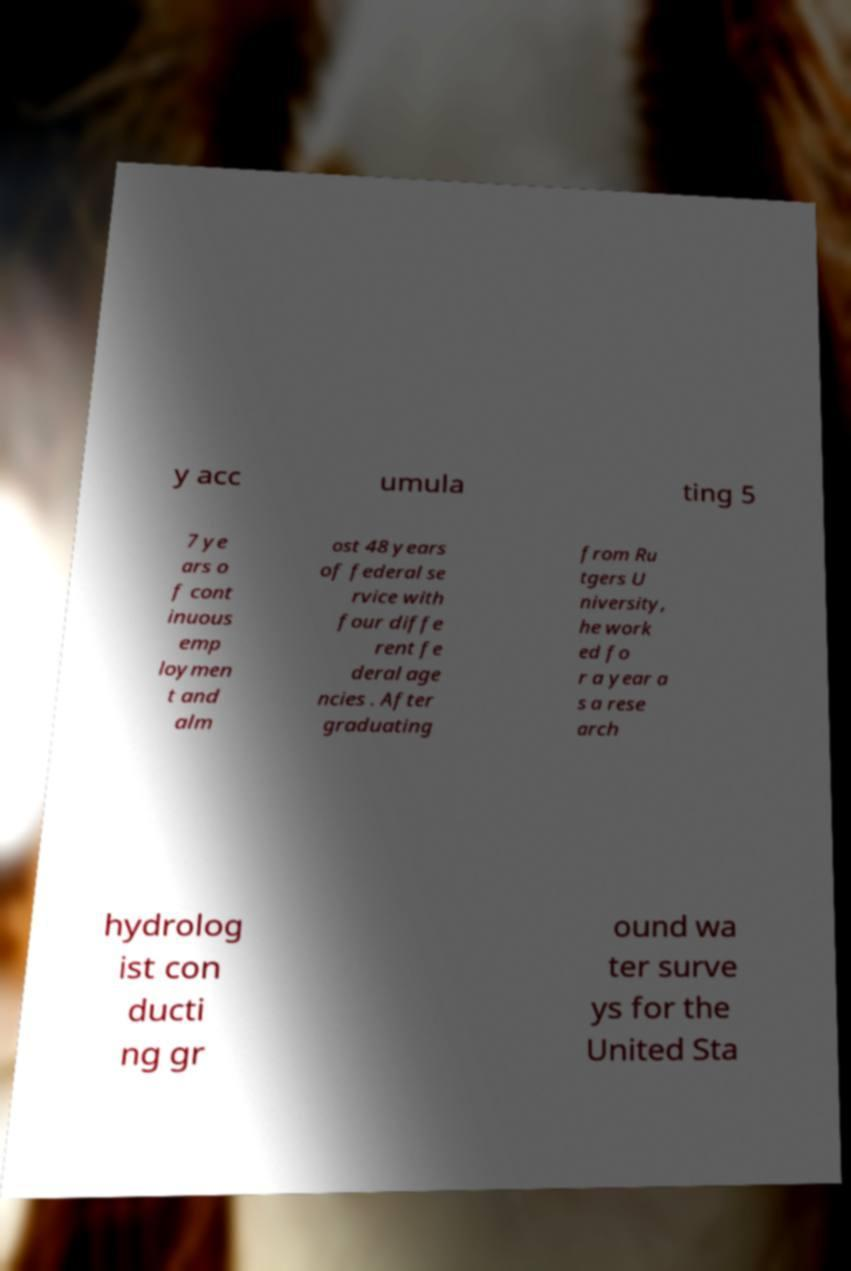I need the written content from this picture converted into text. Can you do that? y acc umula ting 5 7 ye ars o f cont inuous emp loymen t and alm ost 48 years of federal se rvice with four diffe rent fe deral age ncies . After graduating from Ru tgers U niversity, he work ed fo r a year a s a rese arch hydrolog ist con ducti ng gr ound wa ter surve ys for the United Sta 